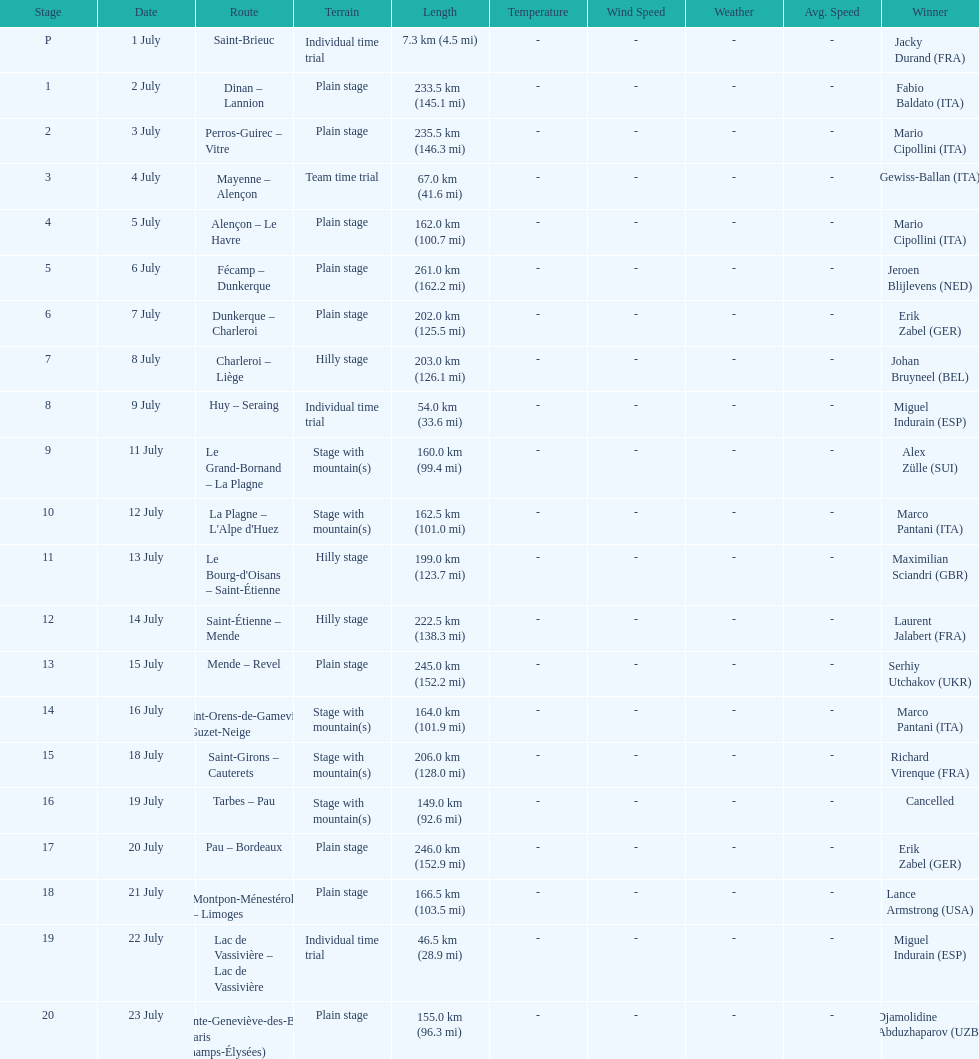How many routes have below 100 km total? 4. 